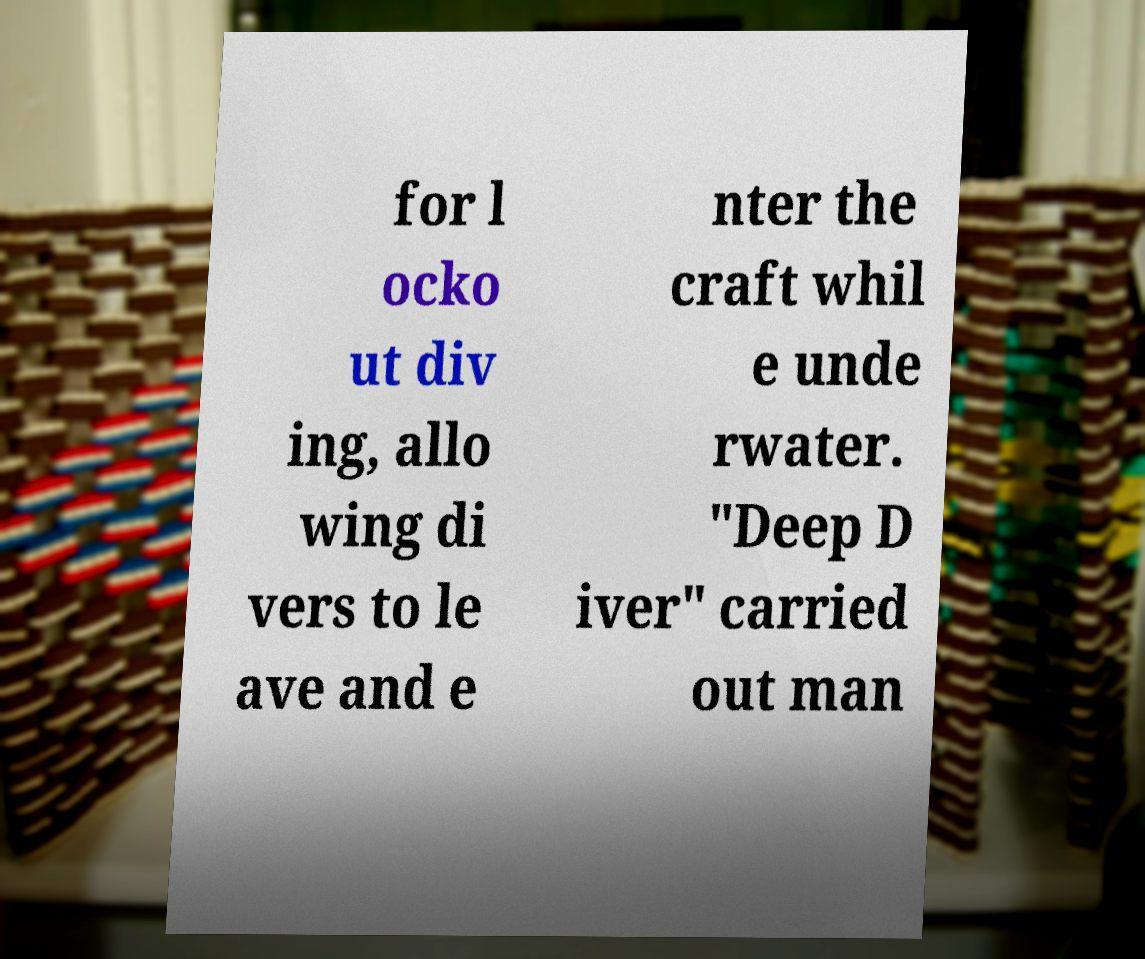Could you extract and type out the text from this image? for l ocko ut div ing, allo wing di vers to le ave and e nter the craft whil e unde rwater. "Deep D iver" carried out man 